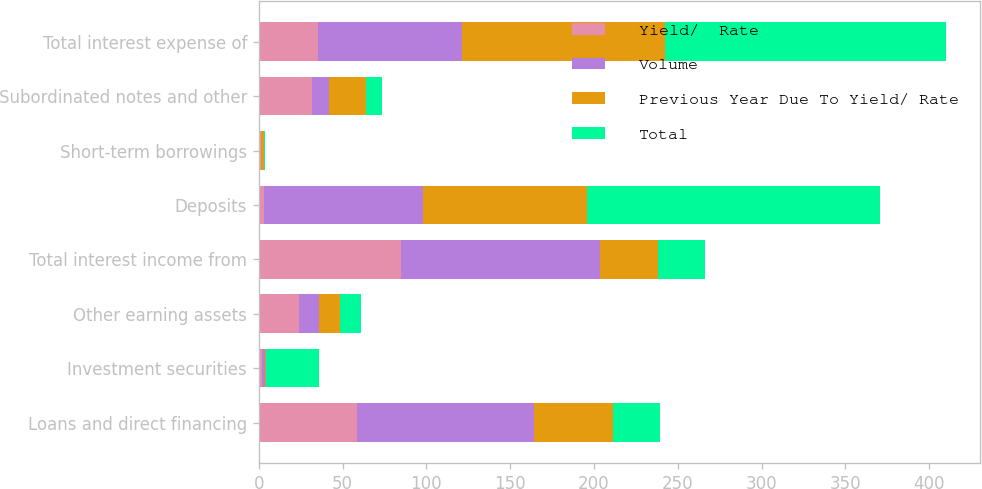Convert chart. <chart><loc_0><loc_0><loc_500><loc_500><stacked_bar_chart><ecel><fcel>Loans and direct financing<fcel>Investment securities<fcel>Other earning assets<fcel>Total interest income from<fcel>Deposits<fcel>Short-term borrowings<fcel>Subordinated notes and other<fcel>Total interest expense of<nl><fcel>Yield/  Rate<fcel>58.6<fcel>1.9<fcel>24.2<fcel>84.7<fcel>3<fcel>1.2<fcel>32<fcel>35.4<nl><fcel>Volume<fcel>105.6<fcel>2.1<fcel>11.5<fcel>119.2<fcel>94.8<fcel>0.3<fcel>10<fcel>85.9<nl><fcel>Previous Year Due To Yield/ Rate<fcel>47<fcel>0.2<fcel>12.7<fcel>34.5<fcel>97.8<fcel>1.5<fcel>22<fcel>121.3<nl><fcel>Total<fcel>27.95<fcel>31.7<fcel>12.5<fcel>27.95<fcel>174.9<fcel>0.6<fcel>9.4<fcel>167.5<nl></chart> 